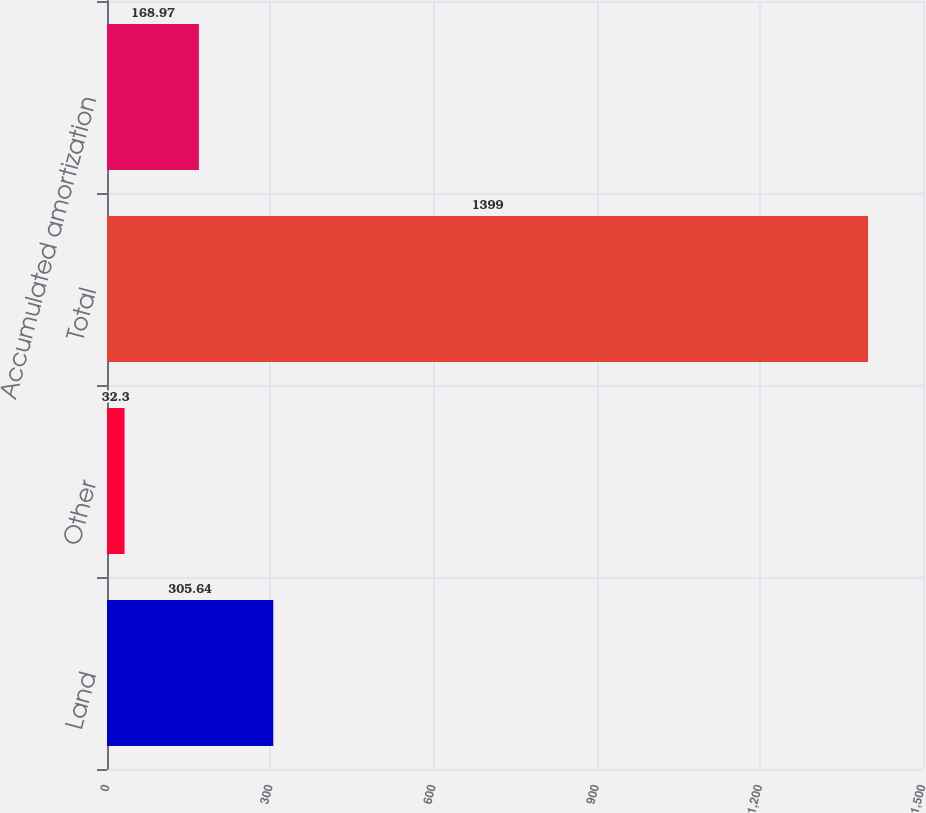<chart> <loc_0><loc_0><loc_500><loc_500><bar_chart><fcel>Land<fcel>Other<fcel>Total<fcel>Accumulated amortization<nl><fcel>305.64<fcel>32.3<fcel>1399<fcel>168.97<nl></chart> 